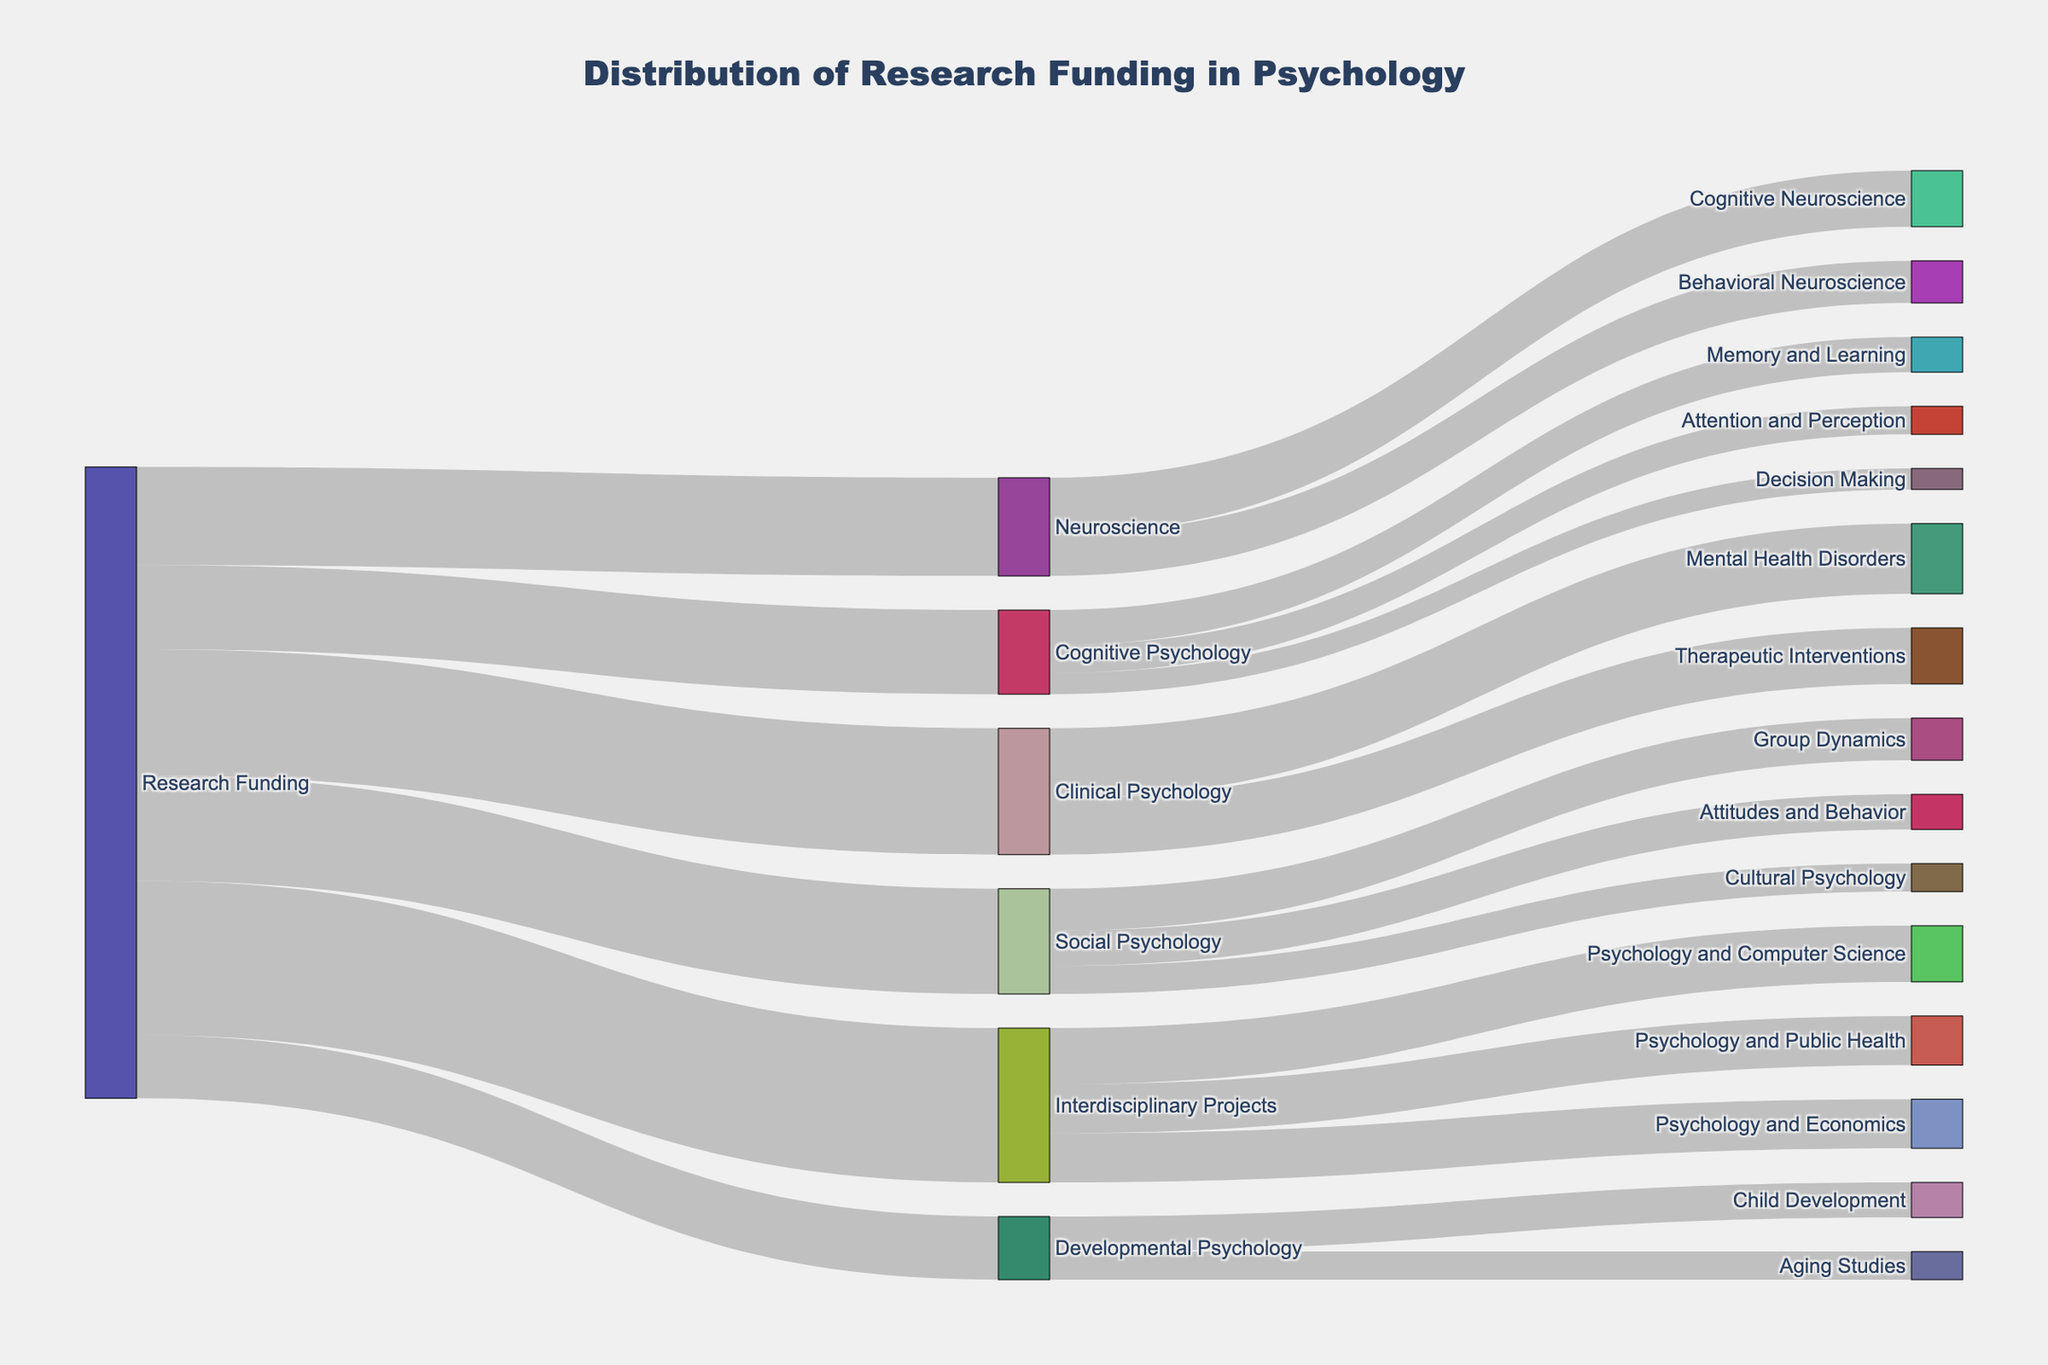How much research funding is allocated to Cognitive Psychology? From the diagram, the funding amount is displayed for each sub-discipline sourced from "Research Funding." Look for the line going from "Research Funding" to "Cognitive Psychology."
Answer: $12,000,000 What is the combined funding for sub-disciplines under Social Psychology? There are three sub-disciplines under Social Psychology: Group Dynamics, Attitudes and Behavior, and Cultural Psychology. Summing their values: $6,000,000 + $5,000,000 + $4,000,000.
Answer: $15,000,000 Which sub-discipline receives the highest amount of funding? Compare the values of all target nodes. The sub-discipline with the highest funding value will have the most significant flow from its source.
Answer: Mental Health Disorders How much funding is dedicated to Interdisciplinary Projects in total? Look for the total amount that flows from "Research Funding" to "Interdisciplinary Projects".
Answer: $22,000,000 Across all sub-disciplines of Clinical Psychology, what is the total funding amount? Clinical Psychology branches into Mental Health Disorders and Therapeutic Interventions. Adding their values: $10,000,000 + $8,000,000.
Answer: $18,000,000 Which has more funding: Interdisciplinary Projects or Neuroscience? Compare the total funding amounts from "Research Funding" to "Interdisciplinary Projects" and "Neuroscience".
Answer: Interdisciplinary Projects What funding amount is allocated to Child Development compared to Aging Studies? Look for the branches of Developmental Psychology leading to Child Development and Aging Studies, then compare their values.
Answer: $5,000,000 vs. $4,000,000 How many sub-disciplines are there under Cognitive Psychology? Count the number of branches that stem from Cognitive Psychology.
Answer: 3 Is the funding for Psychology and Computer Science higher than for Psychology and Public Health? Compare the funding values for these two interdisciplinary projects from the Interdisciplinary Projects node.
Answer: Yes What percentage of the total funding is allocated to Cognitive Neuroscience within Neuroscience? Find the value for Cognitive Neuroscience and divide it by the total for Neuroscience, then convert it to a percentage: ($8,000,000 / $14,000,000) * 100.
Answer: 57.14% 